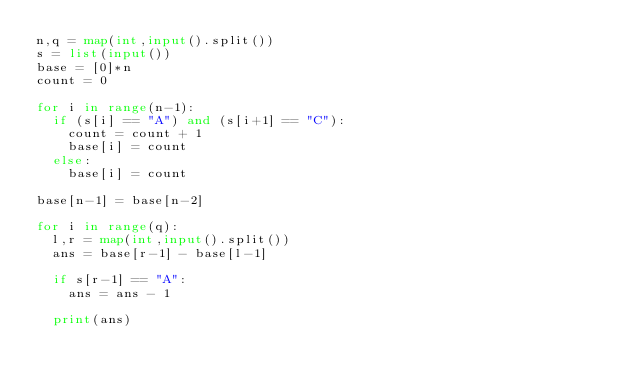<code> <loc_0><loc_0><loc_500><loc_500><_Python_>n,q = map(int,input().split())
s = list(input())
base = [0]*n
count = 0

for i in range(n-1):
  if (s[i] == "A") and (s[i+1] == "C"):
    count = count + 1
    base[i] = count
  else:
    base[i] = count

base[n-1] = base[n-2]

for i in range(q):
  l,r = map(int,input().split())
  ans = base[r-1] - base[l-1]
  
  if s[r-1] == "A":
    ans = ans - 1
    
  print(ans)</code> 